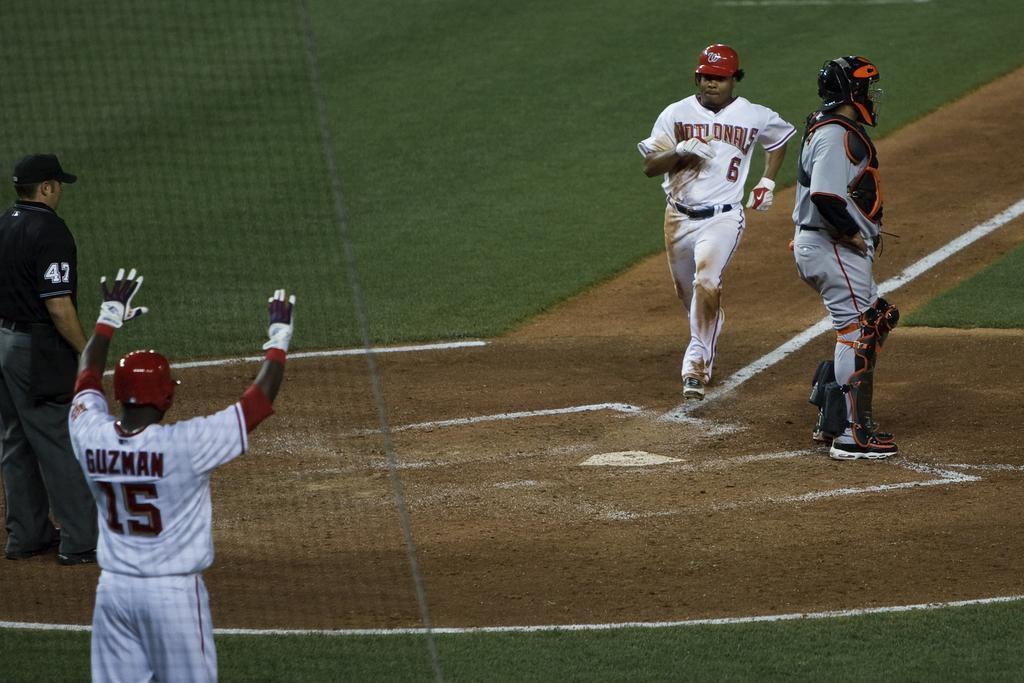How would you summarize this image in a sentence or two? In the foreground of this image, at the bottom and the top, there is grassland. On the left, there is a net behind it, there is a man in white T shirt and a man in black T shirt are standing. On the right, there is a man standing and a man running on the ground. 